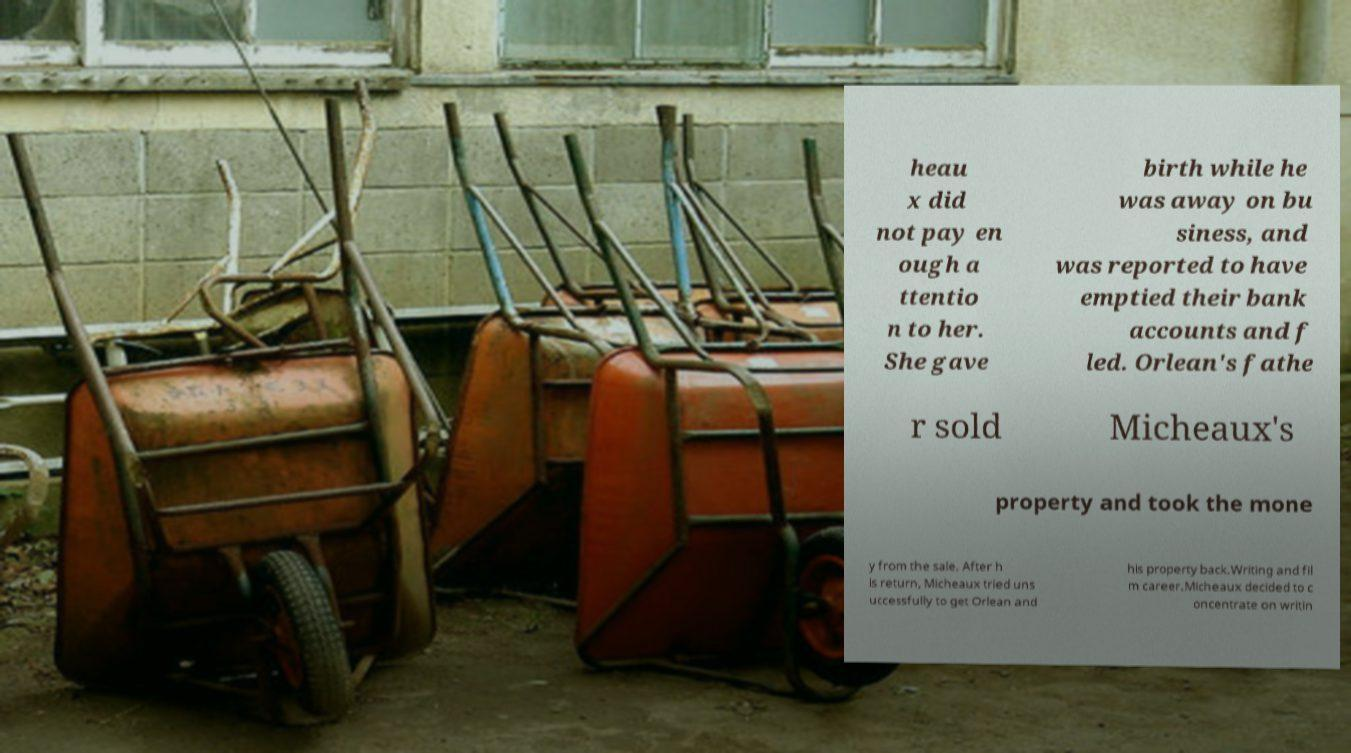For documentation purposes, I need the text within this image transcribed. Could you provide that? heau x did not pay en ough a ttentio n to her. She gave birth while he was away on bu siness, and was reported to have emptied their bank accounts and f led. Orlean's fathe r sold Micheaux's property and took the mone y from the sale. After h is return, Micheaux tried uns uccessfully to get Orlean and his property back.Writing and fil m career.Micheaux decided to c oncentrate on writin 